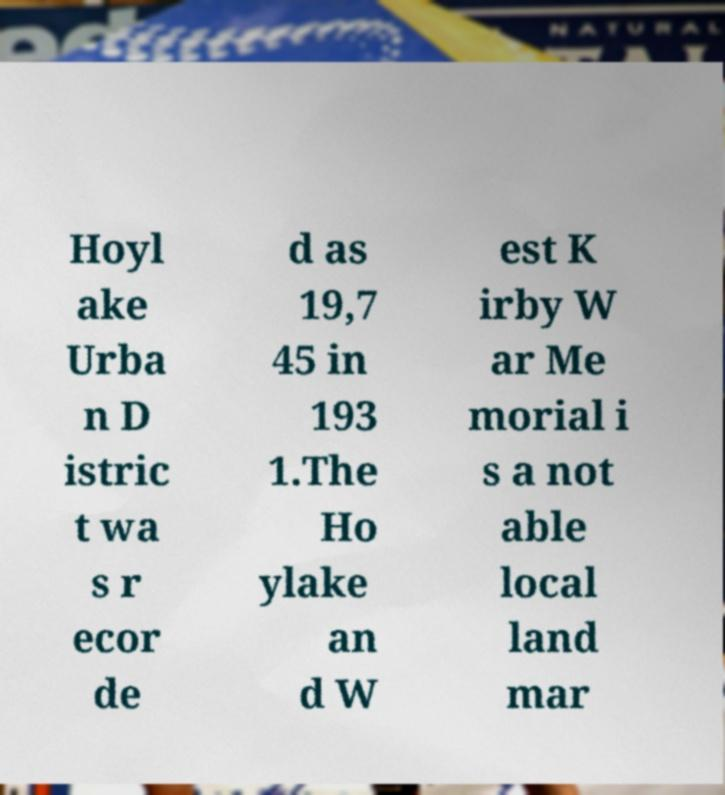What messages or text are displayed in this image? I need them in a readable, typed format. Hoyl ake Urba n D istric t wa s r ecor de d as 19,7 45 in 193 1.The Ho ylake an d W est K irby W ar Me morial i s a not able local land mar 